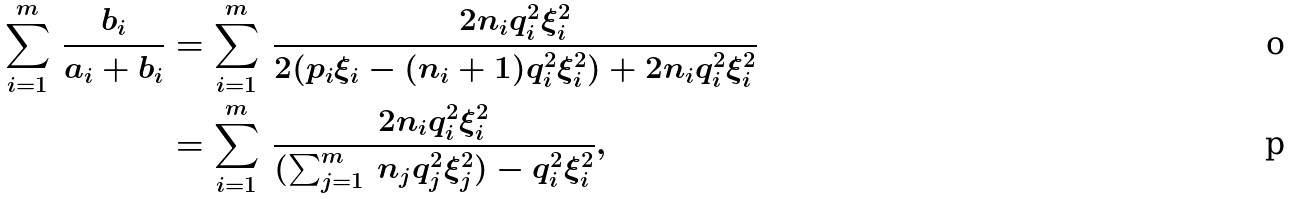Convert formula to latex. <formula><loc_0><loc_0><loc_500><loc_500>\sum _ { i = 1 } ^ { m } \, \frac { b _ { i } } { a _ { i } + b _ { i } } & = \sum _ { i = 1 } ^ { m } \, \frac { 2 n _ { i } q _ { i } ^ { 2 } \xi _ { i } ^ { 2 } } { 2 ( p _ { i } \xi _ { i } - ( n _ { i } + 1 ) q _ { i } ^ { 2 } \xi _ { i } ^ { 2 } ) + 2 n _ { i } q _ { i } ^ { 2 } \xi _ { i } ^ { 2 } } \\ & = \sum _ { i = 1 } ^ { m } \, \frac { 2 n _ { i } q _ { i } ^ { 2 } \xi _ { i } ^ { 2 } } { ( \sum _ { j = 1 } ^ { m } \, n _ { j } q _ { j } ^ { 2 } \xi _ { j } ^ { 2 } ) - q _ { i } ^ { 2 } \xi _ { i } ^ { 2 } } ,</formula> 